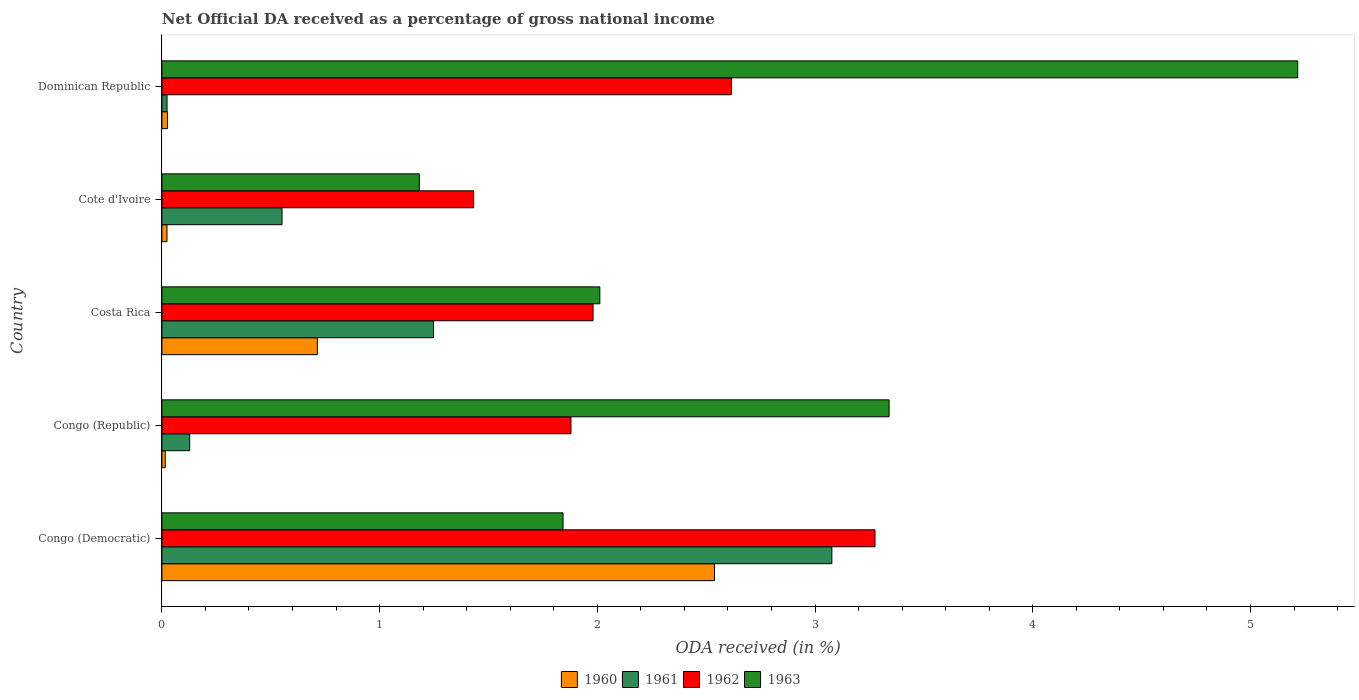How many groups of bars are there?
Provide a succinct answer. 5. Are the number of bars per tick equal to the number of legend labels?
Ensure brevity in your answer.  Yes. What is the label of the 2nd group of bars from the top?
Provide a succinct answer. Cote d'Ivoire. What is the net official DA received in 1963 in Dominican Republic?
Keep it short and to the point. 5.22. Across all countries, what is the maximum net official DA received in 1960?
Make the answer very short. 2.54. Across all countries, what is the minimum net official DA received in 1962?
Provide a succinct answer. 1.43. In which country was the net official DA received in 1961 maximum?
Keep it short and to the point. Congo (Democratic). In which country was the net official DA received in 1963 minimum?
Offer a very short reply. Cote d'Ivoire. What is the total net official DA received in 1961 in the graph?
Your response must be concise. 5.03. What is the difference between the net official DA received in 1960 in Costa Rica and that in Dominican Republic?
Your answer should be compact. 0.69. What is the difference between the net official DA received in 1960 in Congo (Democratic) and the net official DA received in 1962 in Congo (Republic)?
Give a very brief answer. 0.66. What is the average net official DA received in 1963 per country?
Keep it short and to the point. 2.72. What is the difference between the net official DA received in 1963 and net official DA received in 1960 in Cote d'Ivoire?
Keep it short and to the point. 1.16. In how many countries, is the net official DA received in 1961 greater than 3.4 %?
Make the answer very short. 0. What is the ratio of the net official DA received in 1961 in Congo (Democratic) to that in Congo (Republic)?
Your answer should be very brief. 24.11. Is the net official DA received in 1963 in Costa Rica less than that in Dominican Republic?
Your response must be concise. Yes. Is the difference between the net official DA received in 1963 in Congo (Republic) and Cote d'Ivoire greater than the difference between the net official DA received in 1960 in Congo (Republic) and Cote d'Ivoire?
Make the answer very short. Yes. What is the difference between the highest and the second highest net official DA received in 1961?
Your response must be concise. 1.83. What is the difference between the highest and the lowest net official DA received in 1962?
Ensure brevity in your answer.  1.84. Is the sum of the net official DA received in 1963 in Congo (Republic) and Dominican Republic greater than the maximum net official DA received in 1961 across all countries?
Offer a very short reply. Yes. Is it the case that in every country, the sum of the net official DA received in 1962 and net official DA received in 1960 is greater than the sum of net official DA received in 1963 and net official DA received in 1961?
Keep it short and to the point. Yes. Is it the case that in every country, the sum of the net official DA received in 1962 and net official DA received in 1963 is greater than the net official DA received in 1961?
Your response must be concise. Yes. Are all the bars in the graph horizontal?
Provide a succinct answer. Yes. How many countries are there in the graph?
Keep it short and to the point. 5. What is the difference between two consecutive major ticks on the X-axis?
Make the answer very short. 1. Are the values on the major ticks of X-axis written in scientific E-notation?
Give a very brief answer. No. Where does the legend appear in the graph?
Offer a very short reply. Bottom center. How many legend labels are there?
Give a very brief answer. 4. What is the title of the graph?
Give a very brief answer. Net Official DA received as a percentage of gross national income. What is the label or title of the X-axis?
Make the answer very short. ODA received (in %). What is the ODA received (in %) in 1960 in Congo (Democratic)?
Provide a succinct answer. 2.54. What is the ODA received (in %) in 1961 in Congo (Democratic)?
Ensure brevity in your answer.  3.08. What is the ODA received (in %) in 1962 in Congo (Democratic)?
Provide a succinct answer. 3.28. What is the ODA received (in %) of 1963 in Congo (Democratic)?
Give a very brief answer. 1.84. What is the ODA received (in %) in 1960 in Congo (Republic)?
Provide a succinct answer. 0.02. What is the ODA received (in %) in 1961 in Congo (Republic)?
Provide a short and direct response. 0.13. What is the ODA received (in %) of 1962 in Congo (Republic)?
Make the answer very short. 1.88. What is the ODA received (in %) of 1963 in Congo (Republic)?
Give a very brief answer. 3.34. What is the ODA received (in %) in 1960 in Costa Rica?
Provide a short and direct response. 0.71. What is the ODA received (in %) in 1961 in Costa Rica?
Provide a succinct answer. 1.25. What is the ODA received (in %) of 1962 in Costa Rica?
Keep it short and to the point. 1.98. What is the ODA received (in %) in 1963 in Costa Rica?
Keep it short and to the point. 2.01. What is the ODA received (in %) of 1960 in Cote d'Ivoire?
Keep it short and to the point. 0.02. What is the ODA received (in %) in 1961 in Cote d'Ivoire?
Make the answer very short. 0.55. What is the ODA received (in %) of 1962 in Cote d'Ivoire?
Ensure brevity in your answer.  1.43. What is the ODA received (in %) of 1963 in Cote d'Ivoire?
Offer a terse response. 1.18. What is the ODA received (in %) of 1960 in Dominican Republic?
Your answer should be compact. 0.03. What is the ODA received (in %) of 1961 in Dominican Republic?
Your response must be concise. 0.02. What is the ODA received (in %) of 1962 in Dominican Republic?
Offer a terse response. 2.62. What is the ODA received (in %) in 1963 in Dominican Republic?
Your response must be concise. 5.22. Across all countries, what is the maximum ODA received (in %) of 1960?
Give a very brief answer. 2.54. Across all countries, what is the maximum ODA received (in %) of 1961?
Offer a very short reply. 3.08. Across all countries, what is the maximum ODA received (in %) in 1962?
Offer a terse response. 3.28. Across all countries, what is the maximum ODA received (in %) of 1963?
Your answer should be compact. 5.22. Across all countries, what is the minimum ODA received (in %) of 1960?
Your answer should be compact. 0.02. Across all countries, what is the minimum ODA received (in %) of 1961?
Give a very brief answer. 0.02. Across all countries, what is the minimum ODA received (in %) of 1962?
Offer a very short reply. 1.43. Across all countries, what is the minimum ODA received (in %) of 1963?
Make the answer very short. 1.18. What is the total ODA received (in %) in 1960 in the graph?
Offer a terse response. 3.32. What is the total ODA received (in %) in 1961 in the graph?
Your answer should be very brief. 5.03. What is the total ODA received (in %) of 1962 in the graph?
Ensure brevity in your answer.  11.18. What is the total ODA received (in %) in 1963 in the graph?
Keep it short and to the point. 13.59. What is the difference between the ODA received (in %) in 1960 in Congo (Democratic) and that in Congo (Republic)?
Give a very brief answer. 2.52. What is the difference between the ODA received (in %) in 1961 in Congo (Democratic) and that in Congo (Republic)?
Give a very brief answer. 2.95. What is the difference between the ODA received (in %) of 1962 in Congo (Democratic) and that in Congo (Republic)?
Provide a short and direct response. 1.4. What is the difference between the ODA received (in %) in 1963 in Congo (Democratic) and that in Congo (Republic)?
Your response must be concise. -1.5. What is the difference between the ODA received (in %) in 1960 in Congo (Democratic) and that in Costa Rica?
Keep it short and to the point. 1.82. What is the difference between the ODA received (in %) of 1961 in Congo (Democratic) and that in Costa Rica?
Offer a very short reply. 1.83. What is the difference between the ODA received (in %) in 1962 in Congo (Democratic) and that in Costa Rica?
Your answer should be very brief. 1.29. What is the difference between the ODA received (in %) in 1963 in Congo (Democratic) and that in Costa Rica?
Make the answer very short. -0.17. What is the difference between the ODA received (in %) in 1960 in Congo (Democratic) and that in Cote d'Ivoire?
Offer a terse response. 2.51. What is the difference between the ODA received (in %) of 1961 in Congo (Democratic) and that in Cote d'Ivoire?
Give a very brief answer. 2.53. What is the difference between the ODA received (in %) in 1962 in Congo (Democratic) and that in Cote d'Ivoire?
Your response must be concise. 1.84. What is the difference between the ODA received (in %) in 1963 in Congo (Democratic) and that in Cote d'Ivoire?
Your answer should be very brief. 0.66. What is the difference between the ODA received (in %) in 1960 in Congo (Democratic) and that in Dominican Republic?
Your answer should be compact. 2.51. What is the difference between the ODA received (in %) in 1961 in Congo (Democratic) and that in Dominican Republic?
Offer a very short reply. 3.05. What is the difference between the ODA received (in %) in 1962 in Congo (Democratic) and that in Dominican Republic?
Offer a very short reply. 0.66. What is the difference between the ODA received (in %) in 1963 in Congo (Democratic) and that in Dominican Republic?
Your answer should be compact. -3.37. What is the difference between the ODA received (in %) in 1960 in Congo (Republic) and that in Costa Rica?
Provide a short and direct response. -0.7. What is the difference between the ODA received (in %) of 1961 in Congo (Republic) and that in Costa Rica?
Provide a short and direct response. -1.12. What is the difference between the ODA received (in %) in 1962 in Congo (Republic) and that in Costa Rica?
Offer a terse response. -0.1. What is the difference between the ODA received (in %) in 1963 in Congo (Republic) and that in Costa Rica?
Give a very brief answer. 1.33. What is the difference between the ODA received (in %) of 1960 in Congo (Republic) and that in Cote d'Ivoire?
Provide a short and direct response. -0.01. What is the difference between the ODA received (in %) of 1961 in Congo (Republic) and that in Cote d'Ivoire?
Offer a terse response. -0.42. What is the difference between the ODA received (in %) in 1962 in Congo (Republic) and that in Cote d'Ivoire?
Ensure brevity in your answer.  0.45. What is the difference between the ODA received (in %) in 1963 in Congo (Republic) and that in Cote d'Ivoire?
Your response must be concise. 2.16. What is the difference between the ODA received (in %) of 1960 in Congo (Republic) and that in Dominican Republic?
Offer a terse response. -0.01. What is the difference between the ODA received (in %) in 1961 in Congo (Republic) and that in Dominican Republic?
Provide a succinct answer. 0.1. What is the difference between the ODA received (in %) of 1962 in Congo (Republic) and that in Dominican Republic?
Your response must be concise. -0.74. What is the difference between the ODA received (in %) of 1963 in Congo (Republic) and that in Dominican Republic?
Ensure brevity in your answer.  -1.88. What is the difference between the ODA received (in %) of 1960 in Costa Rica and that in Cote d'Ivoire?
Offer a very short reply. 0.69. What is the difference between the ODA received (in %) in 1961 in Costa Rica and that in Cote d'Ivoire?
Your response must be concise. 0.7. What is the difference between the ODA received (in %) in 1962 in Costa Rica and that in Cote d'Ivoire?
Offer a terse response. 0.55. What is the difference between the ODA received (in %) of 1963 in Costa Rica and that in Cote d'Ivoire?
Your answer should be compact. 0.83. What is the difference between the ODA received (in %) in 1960 in Costa Rica and that in Dominican Republic?
Provide a short and direct response. 0.69. What is the difference between the ODA received (in %) of 1961 in Costa Rica and that in Dominican Republic?
Give a very brief answer. 1.22. What is the difference between the ODA received (in %) of 1962 in Costa Rica and that in Dominican Republic?
Your answer should be compact. -0.64. What is the difference between the ODA received (in %) in 1963 in Costa Rica and that in Dominican Republic?
Give a very brief answer. -3.21. What is the difference between the ODA received (in %) in 1960 in Cote d'Ivoire and that in Dominican Republic?
Keep it short and to the point. -0. What is the difference between the ODA received (in %) in 1961 in Cote d'Ivoire and that in Dominican Republic?
Your answer should be compact. 0.53. What is the difference between the ODA received (in %) of 1962 in Cote d'Ivoire and that in Dominican Republic?
Your answer should be very brief. -1.18. What is the difference between the ODA received (in %) of 1963 in Cote d'Ivoire and that in Dominican Republic?
Make the answer very short. -4.03. What is the difference between the ODA received (in %) of 1960 in Congo (Democratic) and the ODA received (in %) of 1961 in Congo (Republic)?
Provide a succinct answer. 2.41. What is the difference between the ODA received (in %) of 1960 in Congo (Democratic) and the ODA received (in %) of 1962 in Congo (Republic)?
Give a very brief answer. 0.66. What is the difference between the ODA received (in %) in 1960 in Congo (Democratic) and the ODA received (in %) in 1963 in Congo (Republic)?
Provide a succinct answer. -0.8. What is the difference between the ODA received (in %) in 1961 in Congo (Democratic) and the ODA received (in %) in 1962 in Congo (Republic)?
Keep it short and to the point. 1.2. What is the difference between the ODA received (in %) in 1961 in Congo (Democratic) and the ODA received (in %) in 1963 in Congo (Republic)?
Provide a short and direct response. -0.26. What is the difference between the ODA received (in %) in 1962 in Congo (Democratic) and the ODA received (in %) in 1963 in Congo (Republic)?
Make the answer very short. -0.06. What is the difference between the ODA received (in %) in 1960 in Congo (Democratic) and the ODA received (in %) in 1961 in Costa Rica?
Your answer should be very brief. 1.29. What is the difference between the ODA received (in %) in 1960 in Congo (Democratic) and the ODA received (in %) in 1962 in Costa Rica?
Provide a succinct answer. 0.56. What is the difference between the ODA received (in %) of 1960 in Congo (Democratic) and the ODA received (in %) of 1963 in Costa Rica?
Provide a short and direct response. 0.53. What is the difference between the ODA received (in %) of 1961 in Congo (Democratic) and the ODA received (in %) of 1962 in Costa Rica?
Make the answer very short. 1.1. What is the difference between the ODA received (in %) in 1961 in Congo (Democratic) and the ODA received (in %) in 1963 in Costa Rica?
Your answer should be very brief. 1.07. What is the difference between the ODA received (in %) in 1962 in Congo (Democratic) and the ODA received (in %) in 1963 in Costa Rica?
Keep it short and to the point. 1.26. What is the difference between the ODA received (in %) of 1960 in Congo (Democratic) and the ODA received (in %) of 1961 in Cote d'Ivoire?
Offer a very short reply. 1.99. What is the difference between the ODA received (in %) of 1960 in Congo (Democratic) and the ODA received (in %) of 1962 in Cote d'Ivoire?
Your answer should be compact. 1.11. What is the difference between the ODA received (in %) of 1960 in Congo (Democratic) and the ODA received (in %) of 1963 in Cote d'Ivoire?
Offer a terse response. 1.36. What is the difference between the ODA received (in %) of 1961 in Congo (Democratic) and the ODA received (in %) of 1962 in Cote d'Ivoire?
Offer a terse response. 1.65. What is the difference between the ODA received (in %) in 1961 in Congo (Democratic) and the ODA received (in %) in 1963 in Cote d'Ivoire?
Provide a succinct answer. 1.89. What is the difference between the ODA received (in %) in 1962 in Congo (Democratic) and the ODA received (in %) in 1963 in Cote d'Ivoire?
Your answer should be compact. 2.09. What is the difference between the ODA received (in %) of 1960 in Congo (Democratic) and the ODA received (in %) of 1961 in Dominican Republic?
Ensure brevity in your answer.  2.51. What is the difference between the ODA received (in %) in 1960 in Congo (Democratic) and the ODA received (in %) in 1962 in Dominican Republic?
Give a very brief answer. -0.08. What is the difference between the ODA received (in %) in 1960 in Congo (Democratic) and the ODA received (in %) in 1963 in Dominican Republic?
Your response must be concise. -2.68. What is the difference between the ODA received (in %) in 1961 in Congo (Democratic) and the ODA received (in %) in 1962 in Dominican Republic?
Your answer should be compact. 0.46. What is the difference between the ODA received (in %) of 1961 in Congo (Democratic) and the ODA received (in %) of 1963 in Dominican Republic?
Ensure brevity in your answer.  -2.14. What is the difference between the ODA received (in %) of 1962 in Congo (Democratic) and the ODA received (in %) of 1963 in Dominican Republic?
Make the answer very short. -1.94. What is the difference between the ODA received (in %) of 1960 in Congo (Republic) and the ODA received (in %) of 1961 in Costa Rica?
Your answer should be compact. -1.23. What is the difference between the ODA received (in %) in 1960 in Congo (Republic) and the ODA received (in %) in 1962 in Costa Rica?
Your answer should be very brief. -1.96. What is the difference between the ODA received (in %) in 1960 in Congo (Republic) and the ODA received (in %) in 1963 in Costa Rica?
Your response must be concise. -2. What is the difference between the ODA received (in %) in 1961 in Congo (Republic) and the ODA received (in %) in 1962 in Costa Rica?
Ensure brevity in your answer.  -1.85. What is the difference between the ODA received (in %) in 1961 in Congo (Republic) and the ODA received (in %) in 1963 in Costa Rica?
Provide a short and direct response. -1.88. What is the difference between the ODA received (in %) in 1962 in Congo (Republic) and the ODA received (in %) in 1963 in Costa Rica?
Ensure brevity in your answer.  -0.13. What is the difference between the ODA received (in %) in 1960 in Congo (Republic) and the ODA received (in %) in 1961 in Cote d'Ivoire?
Offer a very short reply. -0.54. What is the difference between the ODA received (in %) of 1960 in Congo (Republic) and the ODA received (in %) of 1962 in Cote d'Ivoire?
Provide a short and direct response. -1.42. What is the difference between the ODA received (in %) in 1960 in Congo (Republic) and the ODA received (in %) in 1963 in Cote d'Ivoire?
Your answer should be very brief. -1.17. What is the difference between the ODA received (in %) in 1961 in Congo (Republic) and the ODA received (in %) in 1962 in Cote d'Ivoire?
Give a very brief answer. -1.3. What is the difference between the ODA received (in %) of 1961 in Congo (Republic) and the ODA received (in %) of 1963 in Cote d'Ivoire?
Your response must be concise. -1.05. What is the difference between the ODA received (in %) of 1962 in Congo (Republic) and the ODA received (in %) of 1963 in Cote d'Ivoire?
Offer a very short reply. 0.7. What is the difference between the ODA received (in %) in 1960 in Congo (Republic) and the ODA received (in %) in 1961 in Dominican Republic?
Provide a short and direct response. -0.01. What is the difference between the ODA received (in %) of 1960 in Congo (Republic) and the ODA received (in %) of 1962 in Dominican Republic?
Your response must be concise. -2.6. What is the difference between the ODA received (in %) in 1960 in Congo (Republic) and the ODA received (in %) in 1963 in Dominican Republic?
Offer a very short reply. -5.2. What is the difference between the ODA received (in %) of 1961 in Congo (Republic) and the ODA received (in %) of 1962 in Dominican Republic?
Make the answer very short. -2.49. What is the difference between the ODA received (in %) of 1961 in Congo (Republic) and the ODA received (in %) of 1963 in Dominican Republic?
Keep it short and to the point. -5.09. What is the difference between the ODA received (in %) of 1962 in Congo (Republic) and the ODA received (in %) of 1963 in Dominican Republic?
Your response must be concise. -3.34. What is the difference between the ODA received (in %) of 1960 in Costa Rica and the ODA received (in %) of 1961 in Cote d'Ivoire?
Offer a terse response. 0.16. What is the difference between the ODA received (in %) in 1960 in Costa Rica and the ODA received (in %) in 1962 in Cote d'Ivoire?
Your response must be concise. -0.72. What is the difference between the ODA received (in %) in 1960 in Costa Rica and the ODA received (in %) in 1963 in Cote d'Ivoire?
Keep it short and to the point. -0.47. What is the difference between the ODA received (in %) in 1961 in Costa Rica and the ODA received (in %) in 1962 in Cote d'Ivoire?
Your answer should be compact. -0.18. What is the difference between the ODA received (in %) of 1961 in Costa Rica and the ODA received (in %) of 1963 in Cote d'Ivoire?
Your answer should be very brief. 0.07. What is the difference between the ODA received (in %) in 1962 in Costa Rica and the ODA received (in %) in 1963 in Cote d'Ivoire?
Make the answer very short. 0.8. What is the difference between the ODA received (in %) of 1960 in Costa Rica and the ODA received (in %) of 1961 in Dominican Republic?
Your answer should be compact. 0.69. What is the difference between the ODA received (in %) of 1960 in Costa Rica and the ODA received (in %) of 1962 in Dominican Republic?
Your answer should be very brief. -1.9. What is the difference between the ODA received (in %) in 1960 in Costa Rica and the ODA received (in %) in 1963 in Dominican Republic?
Provide a succinct answer. -4.5. What is the difference between the ODA received (in %) in 1961 in Costa Rica and the ODA received (in %) in 1962 in Dominican Republic?
Provide a succinct answer. -1.37. What is the difference between the ODA received (in %) in 1961 in Costa Rica and the ODA received (in %) in 1963 in Dominican Republic?
Give a very brief answer. -3.97. What is the difference between the ODA received (in %) in 1962 in Costa Rica and the ODA received (in %) in 1963 in Dominican Republic?
Your response must be concise. -3.24. What is the difference between the ODA received (in %) in 1960 in Cote d'Ivoire and the ODA received (in %) in 1961 in Dominican Republic?
Provide a succinct answer. -0. What is the difference between the ODA received (in %) of 1960 in Cote d'Ivoire and the ODA received (in %) of 1962 in Dominican Republic?
Your response must be concise. -2.59. What is the difference between the ODA received (in %) in 1960 in Cote d'Ivoire and the ODA received (in %) in 1963 in Dominican Republic?
Make the answer very short. -5.19. What is the difference between the ODA received (in %) in 1961 in Cote d'Ivoire and the ODA received (in %) in 1962 in Dominican Republic?
Offer a very short reply. -2.06. What is the difference between the ODA received (in %) in 1961 in Cote d'Ivoire and the ODA received (in %) in 1963 in Dominican Republic?
Keep it short and to the point. -4.67. What is the difference between the ODA received (in %) of 1962 in Cote d'Ivoire and the ODA received (in %) of 1963 in Dominican Republic?
Offer a terse response. -3.79. What is the average ODA received (in %) of 1960 per country?
Your answer should be very brief. 0.66. What is the average ODA received (in %) of 1962 per country?
Your answer should be very brief. 2.24. What is the average ODA received (in %) of 1963 per country?
Keep it short and to the point. 2.72. What is the difference between the ODA received (in %) of 1960 and ODA received (in %) of 1961 in Congo (Democratic)?
Your answer should be compact. -0.54. What is the difference between the ODA received (in %) of 1960 and ODA received (in %) of 1962 in Congo (Democratic)?
Offer a very short reply. -0.74. What is the difference between the ODA received (in %) in 1960 and ODA received (in %) in 1963 in Congo (Democratic)?
Keep it short and to the point. 0.7. What is the difference between the ODA received (in %) of 1961 and ODA received (in %) of 1962 in Congo (Democratic)?
Your answer should be very brief. -0.2. What is the difference between the ODA received (in %) in 1961 and ODA received (in %) in 1963 in Congo (Democratic)?
Your answer should be very brief. 1.23. What is the difference between the ODA received (in %) in 1962 and ODA received (in %) in 1963 in Congo (Democratic)?
Ensure brevity in your answer.  1.43. What is the difference between the ODA received (in %) in 1960 and ODA received (in %) in 1961 in Congo (Republic)?
Ensure brevity in your answer.  -0.11. What is the difference between the ODA received (in %) of 1960 and ODA received (in %) of 1962 in Congo (Republic)?
Ensure brevity in your answer.  -1.86. What is the difference between the ODA received (in %) in 1960 and ODA received (in %) in 1963 in Congo (Republic)?
Your answer should be very brief. -3.32. What is the difference between the ODA received (in %) in 1961 and ODA received (in %) in 1962 in Congo (Republic)?
Ensure brevity in your answer.  -1.75. What is the difference between the ODA received (in %) in 1961 and ODA received (in %) in 1963 in Congo (Republic)?
Your answer should be very brief. -3.21. What is the difference between the ODA received (in %) in 1962 and ODA received (in %) in 1963 in Congo (Republic)?
Offer a very short reply. -1.46. What is the difference between the ODA received (in %) of 1960 and ODA received (in %) of 1961 in Costa Rica?
Make the answer very short. -0.53. What is the difference between the ODA received (in %) in 1960 and ODA received (in %) in 1962 in Costa Rica?
Your response must be concise. -1.27. What is the difference between the ODA received (in %) in 1960 and ODA received (in %) in 1963 in Costa Rica?
Ensure brevity in your answer.  -1.3. What is the difference between the ODA received (in %) in 1961 and ODA received (in %) in 1962 in Costa Rica?
Your answer should be compact. -0.73. What is the difference between the ODA received (in %) of 1961 and ODA received (in %) of 1963 in Costa Rica?
Your answer should be compact. -0.76. What is the difference between the ODA received (in %) of 1962 and ODA received (in %) of 1963 in Costa Rica?
Your answer should be compact. -0.03. What is the difference between the ODA received (in %) of 1960 and ODA received (in %) of 1961 in Cote d'Ivoire?
Your response must be concise. -0.53. What is the difference between the ODA received (in %) in 1960 and ODA received (in %) in 1962 in Cote d'Ivoire?
Keep it short and to the point. -1.41. What is the difference between the ODA received (in %) in 1960 and ODA received (in %) in 1963 in Cote d'Ivoire?
Keep it short and to the point. -1.16. What is the difference between the ODA received (in %) of 1961 and ODA received (in %) of 1962 in Cote d'Ivoire?
Your answer should be very brief. -0.88. What is the difference between the ODA received (in %) in 1961 and ODA received (in %) in 1963 in Cote d'Ivoire?
Provide a short and direct response. -0.63. What is the difference between the ODA received (in %) of 1962 and ODA received (in %) of 1963 in Cote d'Ivoire?
Offer a terse response. 0.25. What is the difference between the ODA received (in %) in 1960 and ODA received (in %) in 1961 in Dominican Republic?
Your response must be concise. 0. What is the difference between the ODA received (in %) in 1960 and ODA received (in %) in 1962 in Dominican Republic?
Provide a succinct answer. -2.59. What is the difference between the ODA received (in %) in 1960 and ODA received (in %) in 1963 in Dominican Republic?
Provide a succinct answer. -5.19. What is the difference between the ODA received (in %) of 1961 and ODA received (in %) of 1962 in Dominican Republic?
Keep it short and to the point. -2.59. What is the difference between the ODA received (in %) in 1961 and ODA received (in %) in 1963 in Dominican Republic?
Offer a very short reply. -5.19. What is the difference between the ODA received (in %) in 1962 and ODA received (in %) in 1963 in Dominican Republic?
Ensure brevity in your answer.  -2.6. What is the ratio of the ODA received (in %) in 1960 in Congo (Democratic) to that in Congo (Republic)?
Provide a succinct answer. 164.41. What is the ratio of the ODA received (in %) of 1961 in Congo (Democratic) to that in Congo (Republic)?
Your response must be concise. 24.11. What is the ratio of the ODA received (in %) of 1962 in Congo (Democratic) to that in Congo (Republic)?
Offer a terse response. 1.74. What is the ratio of the ODA received (in %) of 1963 in Congo (Democratic) to that in Congo (Republic)?
Provide a succinct answer. 0.55. What is the ratio of the ODA received (in %) in 1960 in Congo (Democratic) to that in Costa Rica?
Make the answer very short. 3.55. What is the ratio of the ODA received (in %) in 1961 in Congo (Democratic) to that in Costa Rica?
Keep it short and to the point. 2.47. What is the ratio of the ODA received (in %) in 1962 in Congo (Democratic) to that in Costa Rica?
Make the answer very short. 1.65. What is the ratio of the ODA received (in %) in 1963 in Congo (Democratic) to that in Costa Rica?
Provide a succinct answer. 0.92. What is the ratio of the ODA received (in %) of 1960 in Congo (Democratic) to that in Cote d'Ivoire?
Offer a very short reply. 108.64. What is the ratio of the ODA received (in %) of 1961 in Congo (Democratic) to that in Cote d'Ivoire?
Make the answer very short. 5.58. What is the ratio of the ODA received (in %) in 1962 in Congo (Democratic) to that in Cote d'Ivoire?
Give a very brief answer. 2.29. What is the ratio of the ODA received (in %) in 1963 in Congo (Democratic) to that in Cote d'Ivoire?
Ensure brevity in your answer.  1.56. What is the ratio of the ODA received (in %) of 1960 in Congo (Democratic) to that in Dominican Republic?
Offer a terse response. 98.88. What is the ratio of the ODA received (in %) in 1961 in Congo (Democratic) to that in Dominican Republic?
Make the answer very short. 130.37. What is the ratio of the ODA received (in %) of 1962 in Congo (Democratic) to that in Dominican Republic?
Your answer should be compact. 1.25. What is the ratio of the ODA received (in %) of 1963 in Congo (Democratic) to that in Dominican Republic?
Your answer should be very brief. 0.35. What is the ratio of the ODA received (in %) of 1960 in Congo (Republic) to that in Costa Rica?
Your answer should be very brief. 0.02. What is the ratio of the ODA received (in %) in 1961 in Congo (Republic) to that in Costa Rica?
Your answer should be very brief. 0.1. What is the ratio of the ODA received (in %) of 1962 in Congo (Republic) to that in Costa Rica?
Provide a short and direct response. 0.95. What is the ratio of the ODA received (in %) in 1963 in Congo (Republic) to that in Costa Rica?
Offer a very short reply. 1.66. What is the ratio of the ODA received (in %) in 1960 in Congo (Republic) to that in Cote d'Ivoire?
Your answer should be compact. 0.66. What is the ratio of the ODA received (in %) in 1961 in Congo (Republic) to that in Cote d'Ivoire?
Your answer should be compact. 0.23. What is the ratio of the ODA received (in %) in 1962 in Congo (Republic) to that in Cote d'Ivoire?
Keep it short and to the point. 1.31. What is the ratio of the ODA received (in %) in 1963 in Congo (Republic) to that in Cote d'Ivoire?
Your answer should be very brief. 2.83. What is the ratio of the ODA received (in %) in 1960 in Congo (Republic) to that in Dominican Republic?
Provide a short and direct response. 0.6. What is the ratio of the ODA received (in %) in 1961 in Congo (Republic) to that in Dominican Republic?
Give a very brief answer. 5.41. What is the ratio of the ODA received (in %) in 1962 in Congo (Republic) to that in Dominican Republic?
Keep it short and to the point. 0.72. What is the ratio of the ODA received (in %) of 1963 in Congo (Republic) to that in Dominican Republic?
Your response must be concise. 0.64. What is the ratio of the ODA received (in %) of 1960 in Costa Rica to that in Cote d'Ivoire?
Provide a short and direct response. 30.57. What is the ratio of the ODA received (in %) in 1961 in Costa Rica to that in Cote d'Ivoire?
Provide a short and direct response. 2.26. What is the ratio of the ODA received (in %) in 1962 in Costa Rica to that in Cote d'Ivoire?
Keep it short and to the point. 1.38. What is the ratio of the ODA received (in %) of 1963 in Costa Rica to that in Cote d'Ivoire?
Provide a short and direct response. 1.7. What is the ratio of the ODA received (in %) of 1960 in Costa Rica to that in Dominican Republic?
Keep it short and to the point. 27.82. What is the ratio of the ODA received (in %) of 1961 in Costa Rica to that in Dominican Republic?
Provide a succinct answer. 52.85. What is the ratio of the ODA received (in %) in 1962 in Costa Rica to that in Dominican Republic?
Provide a short and direct response. 0.76. What is the ratio of the ODA received (in %) in 1963 in Costa Rica to that in Dominican Republic?
Provide a succinct answer. 0.39. What is the ratio of the ODA received (in %) in 1960 in Cote d'Ivoire to that in Dominican Republic?
Your answer should be compact. 0.91. What is the ratio of the ODA received (in %) in 1961 in Cote d'Ivoire to that in Dominican Republic?
Your response must be concise. 23.38. What is the ratio of the ODA received (in %) of 1962 in Cote d'Ivoire to that in Dominican Republic?
Ensure brevity in your answer.  0.55. What is the ratio of the ODA received (in %) in 1963 in Cote d'Ivoire to that in Dominican Republic?
Offer a terse response. 0.23. What is the difference between the highest and the second highest ODA received (in %) in 1960?
Offer a terse response. 1.82. What is the difference between the highest and the second highest ODA received (in %) of 1961?
Ensure brevity in your answer.  1.83. What is the difference between the highest and the second highest ODA received (in %) of 1962?
Keep it short and to the point. 0.66. What is the difference between the highest and the second highest ODA received (in %) of 1963?
Give a very brief answer. 1.88. What is the difference between the highest and the lowest ODA received (in %) in 1960?
Your answer should be very brief. 2.52. What is the difference between the highest and the lowest ODA received (in %) of 1961?
Your response must be concise. 3.05. What is the difference between the highest and the lowest ODA received (in %) of 1962?
Make the answer very short. 1.84. What is the difference between the highest and the lowest ODA received (in %) in 1963?
Keep it short and to the point. 4.03. 